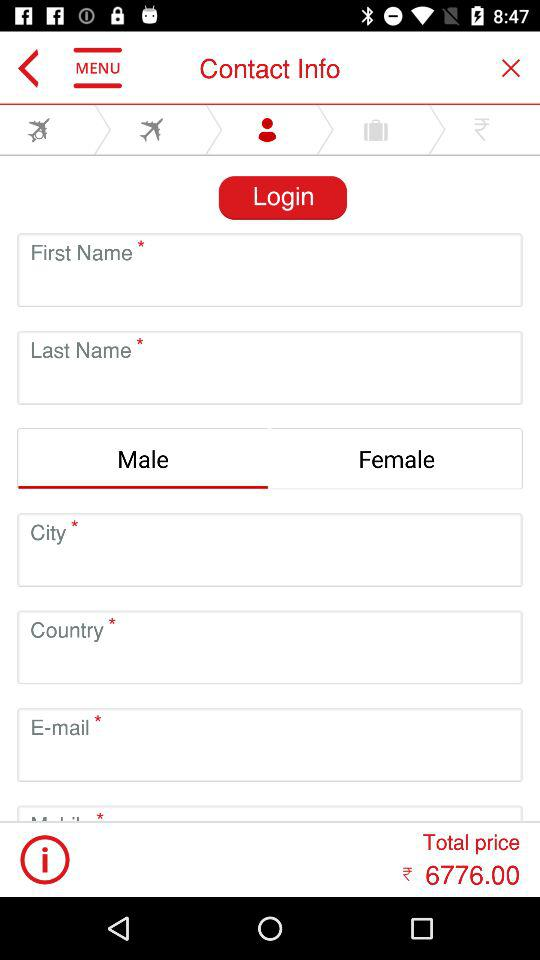What is the total price? The total price is ₹6776.00. 